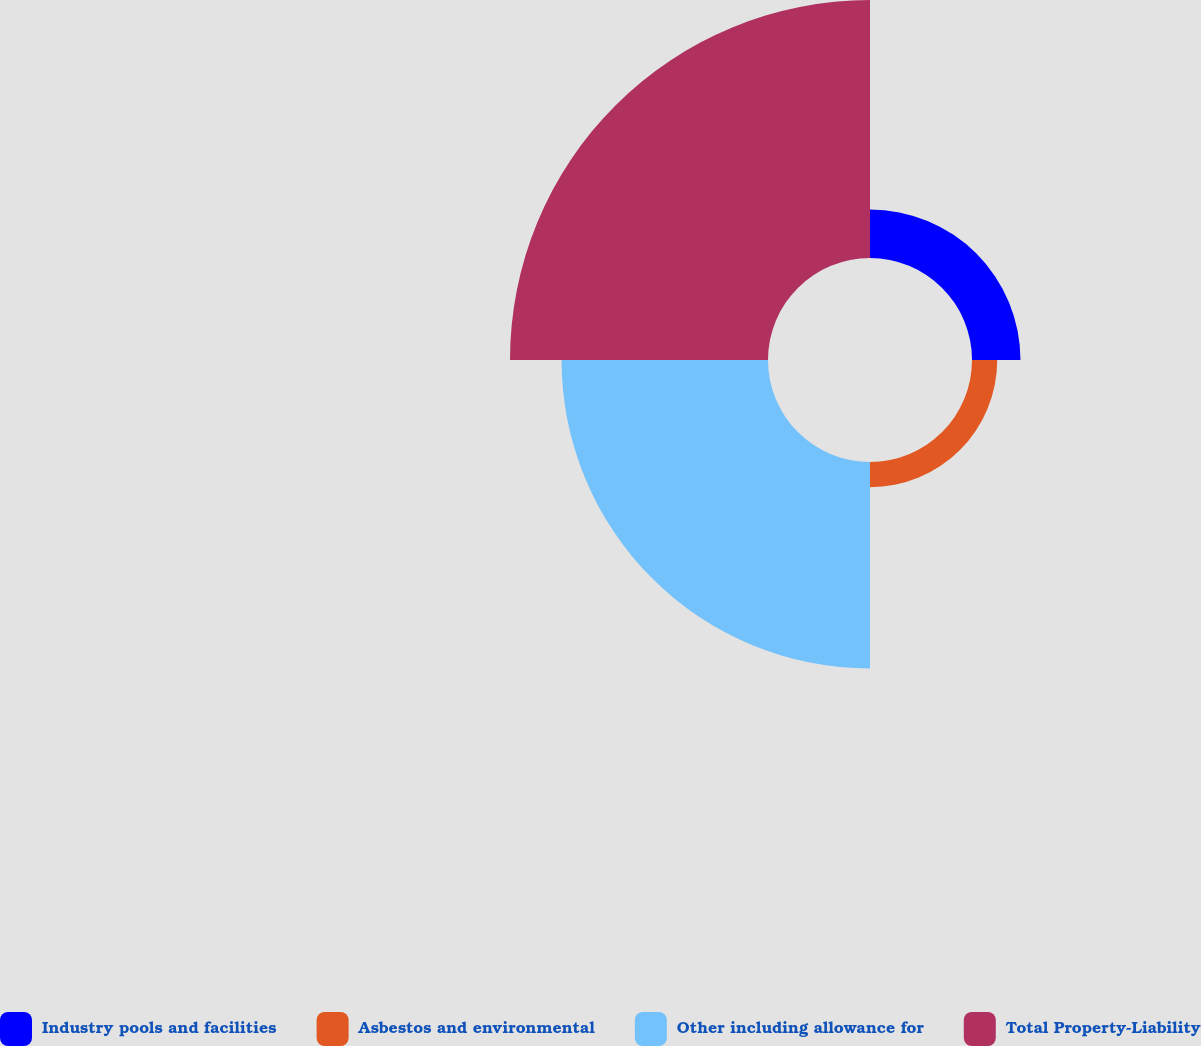Convert chart. <chart><loc_0><loc_0><loc_500><loc_500><pie_chart><fcel>Industry pools and facilities<fcel>Asbestos and environmental<fcel>Other including allowance for<fcel>Total Property-Liability<nl><fcel>9.01%<fcel>4.69%<fcel>38.36%<fcel>47.94%<nl></chart> 